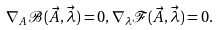<formula> <loc_0><loc_0><loc_500><loc_500>\nabla _ { A } \mathcal { B } ( \vec { A } , \vec { \lambda } ) = 0 , \nabla _ { \lambda } \mathcal { F } ( \vec { A } , \vec { \lambda } ) = 0 .</formula> 